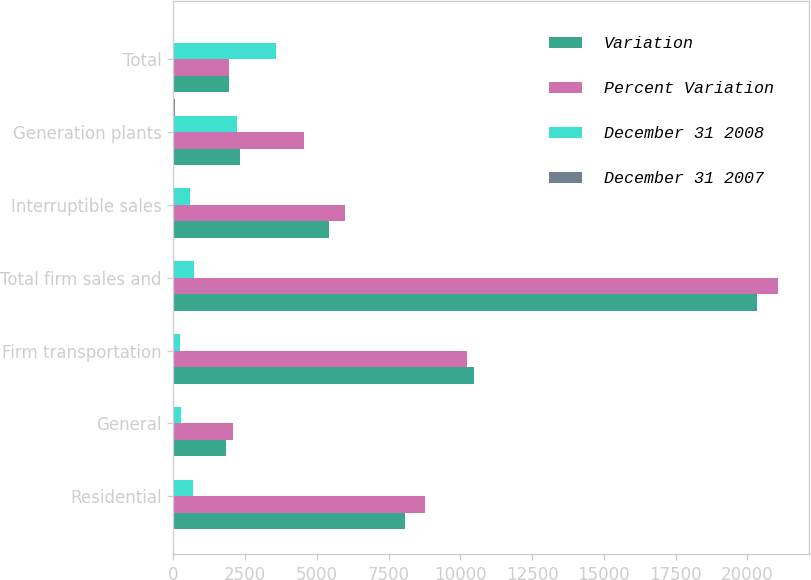Convert chart to OTSL. <chart><loc_0><loc_0><loc_500><loc_500><stacked_bar_chart><ecel><fcel>Residential<fcel>General<fcel>Firm transportation<fcel>Total firm sales and<fcel>Interruptible sales<fcel>Generation plants<fcel>Total<nl><fcel>Variation<fcel>8068<fcel>1816<fcel>10471<fcel>20355<fcel>5409<fcel>2327<fcel>1941<nl><fcel>Percent Variation<fcel>8768<fcel>2066<fcel>10248<fcel>21082<fcel>5983<fcel>4552<fcel>1941<nl><fcel>December 31 2008<fcel>700<fcel>250<fcel>223<fcel>727<fcel>574<fcel>2225<fcel>3563<nl><fcel>December 31 2007<fcel>8<fcel>12.1<fcel>2.2<fcel>3.4<fcel>9.6<fcel>48.9<fcel>10.9<nl></chart> 